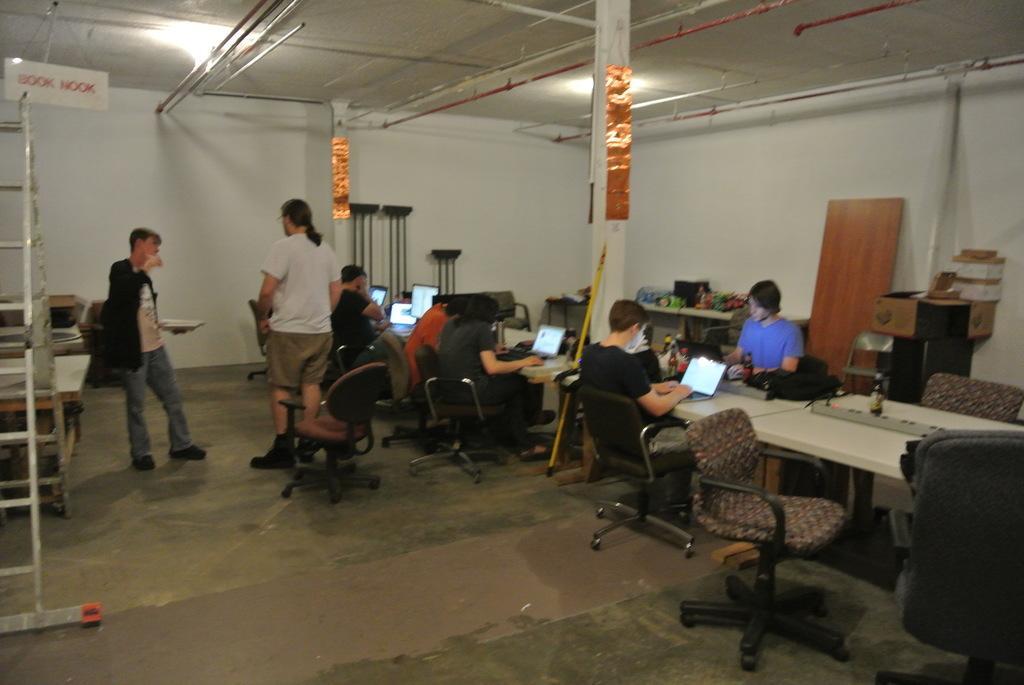In one or two sentences, can you explain what this image depicts? As we can see in the image there is a white color wall, few people standing and sitting on chairs and there is a table. On table are laptops. 